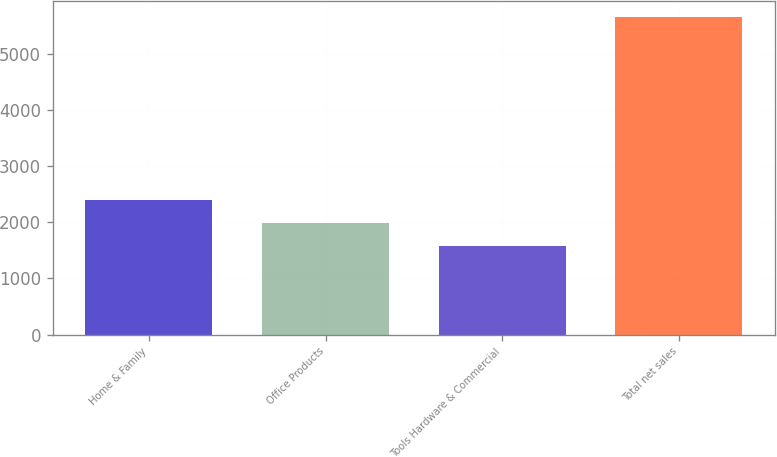Convert chart to OTSL. <chart><loc_0><loc_0><loc_500><loc_500><bar_chart><fcel>Home & Family<fcel>Office Products<fcel>Tools Hardware & Commercial<fcel>Total net sales<nl><fcel>2388.36<fcel>1979.63<fcel>1570.9<fcel>5658.2<nl></chart> 